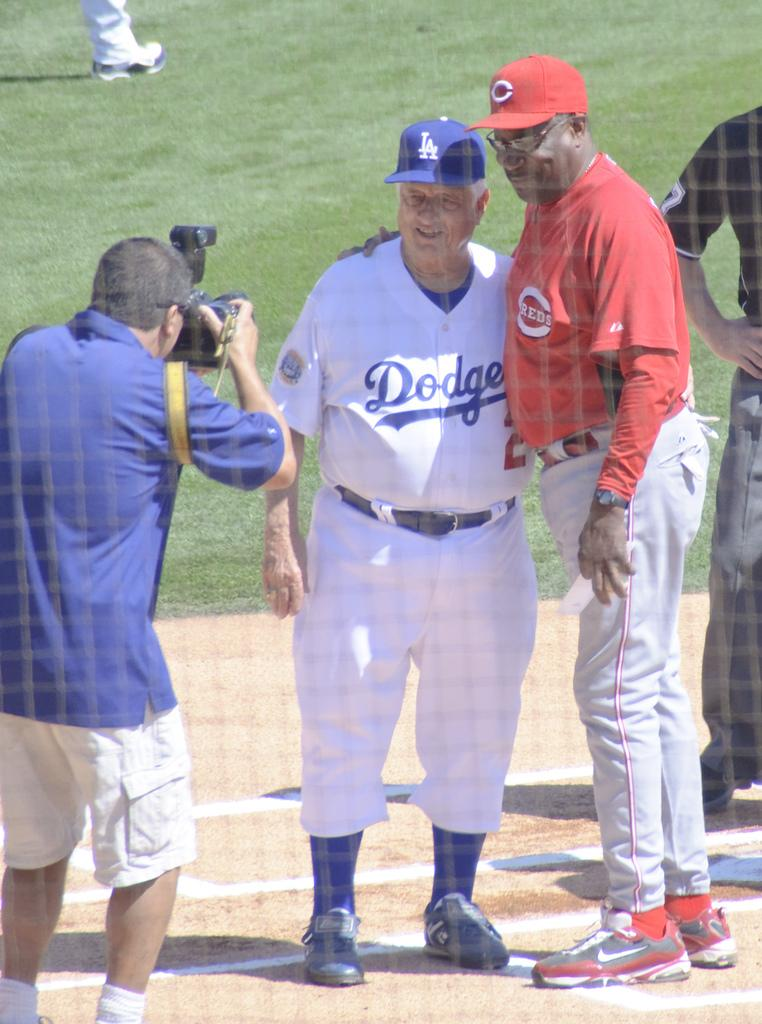<image>
Describe the image concisely. A Dodger and a Red stand together and have their picture taken. 